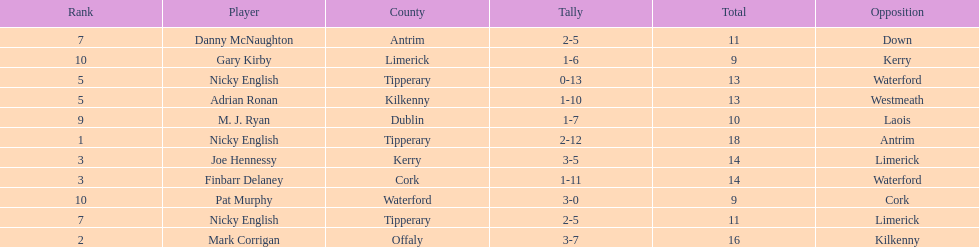Who was the top ranked player in a single game? Nicky English. 